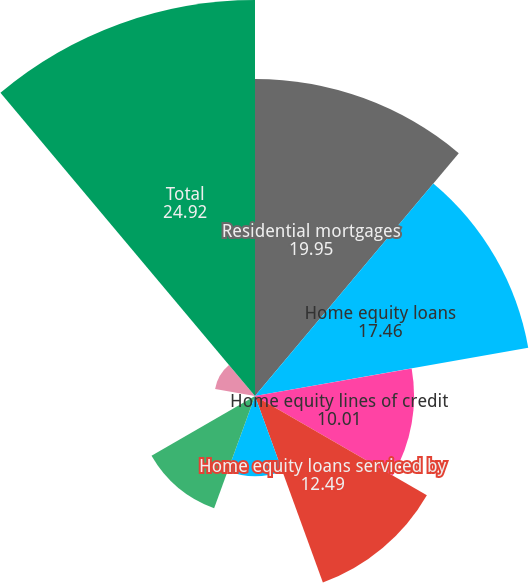Convert chart to OTSL. <chart><loc_0><loc_0><loc_500><loc_500><pie_chart><fcel>Residential mortgages<fcel>Home equity loans<fcel>Home equity lines of credit<fcel>Home equity loans serviced by<fcel>Automobile<fcel>Student<fcel>Credit cards<fcel>Other retail<fcel>Total<nl><fcel>19.95%<fcel>17.46%<fcel>10.01%<fcel>12.49%<fcel>5.04%<fcel>7.52%<fcel>0.06%<fcel>2.55%<fcel>24.92%<nl></chart> 